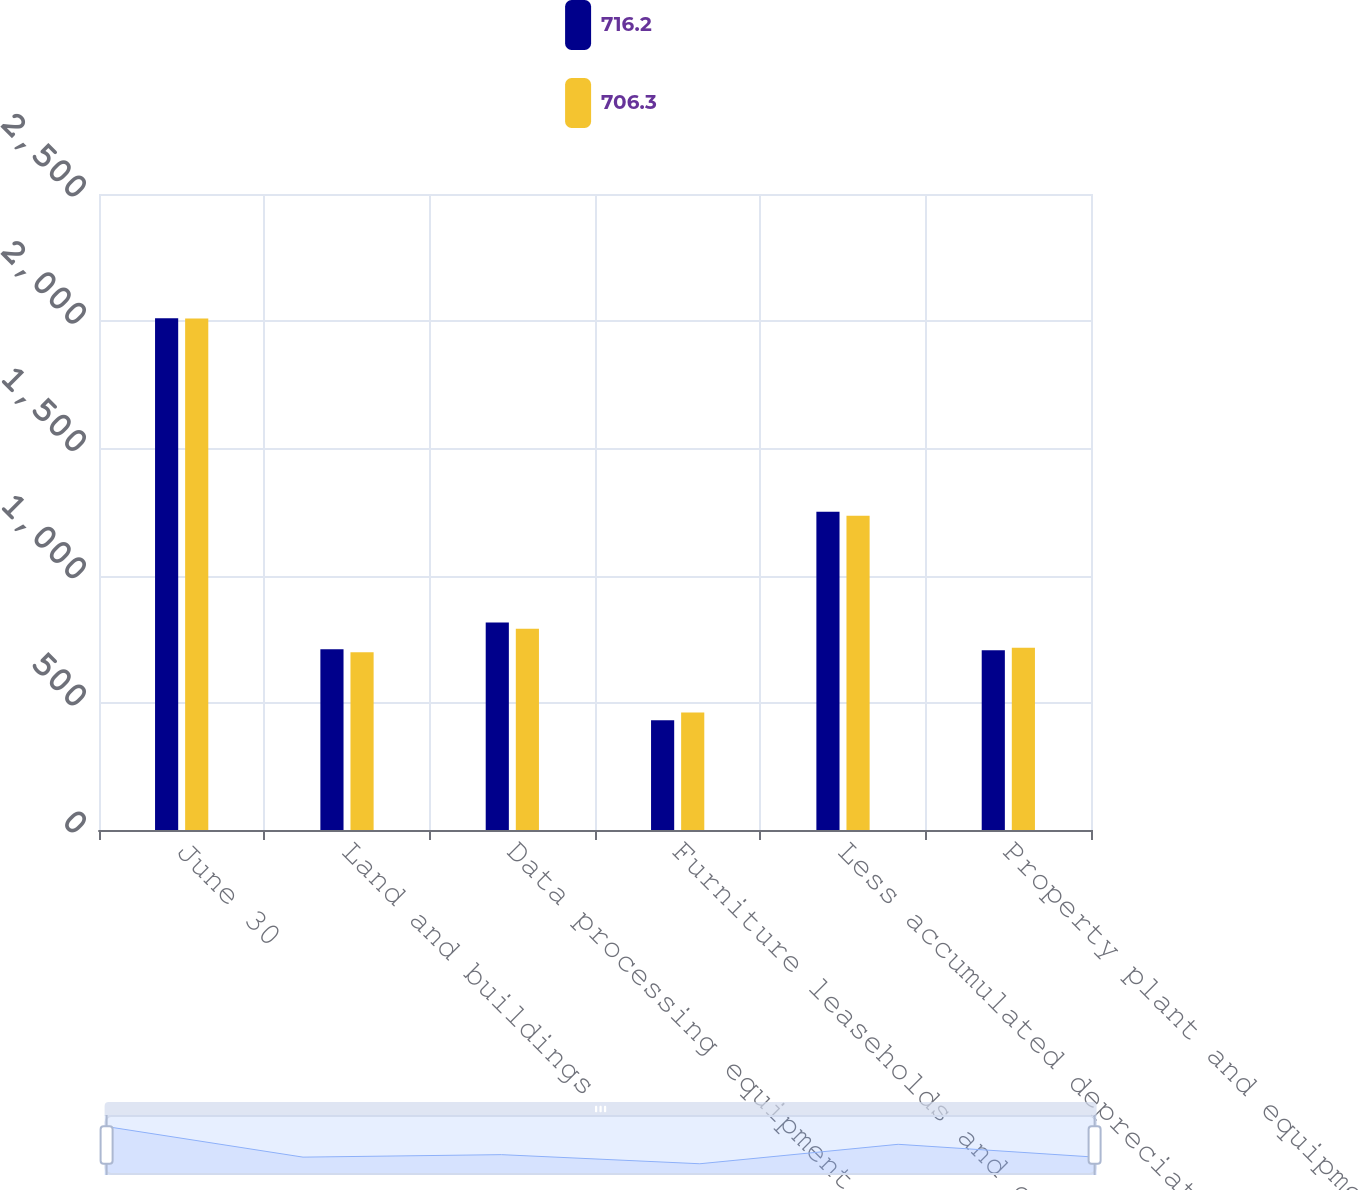Convert chart. <chart><loc_0><loc_0><loc_500><loc_500><stacked_bar_chart><ecel><fcel>June 30<fcel>Land and buildings<fcel>Data processing equipment<fcel>Furniture leaseholds and other<fcel>Less accumulated depreciation<fcel>Property plant and equipment<nl><fcel>716.2<fcel>2012<fcel>710.4<fcel>815.4<fcel>431.6<fcel>1251.1<fcel>706.3<nl><fcel>706.3<fcel>2011<fcel>698.4<fcel>791<fcel>462.3<fcel>1235.5<fcel>716.2<nl></chart> 